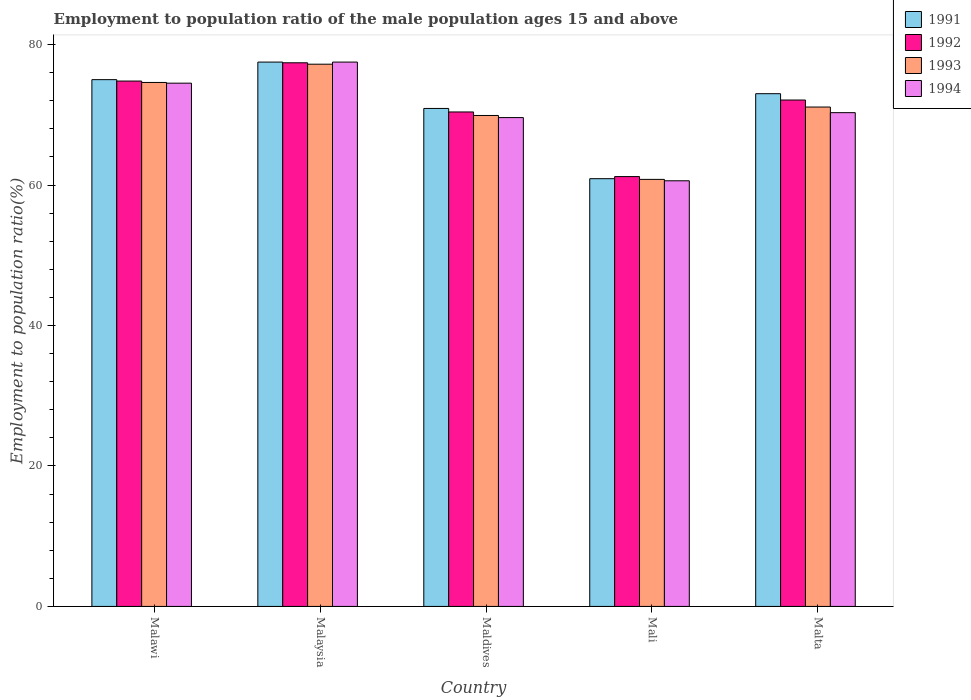How many different coloured bars are there?
Offer a terse response. 4. How many groups of bars are there?
Provide a succinct answer. 5. Are the number of bars per tick equal to the number of legend labels?
Provide a succinct answer. Yes. How many bars are there on the 5th tick from the right?
Provide a succinct answer. 4. What is the label of the 2nd group of bars from the left?
Make the answer very short. Malaysia. In how many cases, is the number of bars for a given country not equal to the number of legend labels?
Ensure brevity in your answer.  0. What is the employment to population ratio in 1993 in Malawi?
Your answer should be very brief. 74.6. Across all countries, what is the maximum employment to population ratio in 1994?
Provide a succinct answer. 77.5. Across all countries, what is the minimum employment to population ratio in 1991?
Your answer should be very brief. 60.9. In which country was the employment to population ratio in 1991 maximum?
Provide a short and direct response. Malaysia. In which country was the employment to population ratio in 1994 minimum?
Keep it short and to the point. Mali. What is the total employment to population ratio in 1993 in the graph?
Your answer should be compact. 353.6. What is the difference between the employment to population ratio in 1993 in Malaysia and that in Maldives?
Provide a succinct answer. 7.3. What is the difference between the employment to population ratio in 1993 in Mali and the employment to population ratio in 1992 in Malawi?
Ensure brevity in your answer.  -14. What is the average employment to population ratio in 1992 per country?
Your answer should be compact. 71.18. What is the difference between the employment to population ratio of/in 1992 and employment to population ratio of/in 1993 in Malaysia?
Your response must be concise. 0.2. What is the ratio of the employment to population ratio in 1993 in Malawi to that in Maldives?
Give a very brief answer. 1.07. Is the employment to population ratio in 1993 in Maldives less than that in Malta?
Your answer should be compact. Yes. What is the difference between the highest and the lowest employment to population ratio in 1991?
Your response must be concise. 16.6. Is it the case that in every country, the sum of the employment to population ratio in 1992 and employment to population ratio in 1993 is greater than the sum of employment to population ratio in 1991 and employment to population ratio in 1994?
Provide a succinct answer. No. What does the 3rd bar from the right in Malta represents?
Keep it short and to the point. 1992. How many bars are there?
Make the answer very short. 20. Are all the bars in the graph horizontal?
Your answer should be very brief. No. What is the difference between two consecutive major ticks on the Y-axis?
Provide a short and direct response. 20. Are the values on the major ticks of Y-axis written in scientific E-notation?
Offer a terse response. No. Does the graph contain any zero values?
Your response must be concise. No. Does the graph contain grids?
Provide a succinct answer. No. Where does the legend appear in the graph?
Your answer should be very brief. Top right. What is the title of the graph?
Your answer should be very brief. Employment to population ratio of the male population ages 15 and above. Does "1964" appear as one of the legend labels in the graph?
Your answer should be very brief. No. What is the Employment to population ratio(%) of 1991 in Malawi?
Provide a succinct answer. 75. What is the Employment to population ratio(%) of 1992 in Malawi?
Provide a short and direct response. 74.8. What is the Employment to population ratio(%) in 1993 in Malawi?
Your response must be concise. 74.6. What is the Employment to population ratio(%) in 1994 in Malawi?
Provide a succinct answer. 74.5. What is the Employment to population ratio(%) of 1991 in Malaysia?
Provide a short and direct response. 77.5. What is the Employment to population ratio(%) of 1992 in Malaysia?
Your response must be concise. 77.4. What is the Employment to population ratio(%) in 1993 in Malaysia?
Ensure brevity in your answer.  77.2. What is the Employment to population ratio(%) in 1994 in Malaysia?
Give a very brief answer. 77.5. What is the Employment to population ratio(%) of 1991 in Maldives?
Your answer should be very brief. 70.9. What is the Employment to population ratio(%) in 1992 in Maldives?
Your answer should be very brief. 70.4. What is the Employment to population ratio(%) of 1993 in Maldives?
Make the answer very short. 69.9. What is the Employment to population ratio(%) in 1994 in Maldives?
Keep it short and to the point. 69.6. What is the Employment to population ratio(%) of 1991 in Mali?
Offer a terse response. 60.9. What is the Employment to population ratio(%) of 1992 in Mali?
Your answer should be compact. 61.2. What is the Employment to population ratio(%) of 1993 in Mali?
Make the answer very short. 60.8. What is the Employment to population ratio(%) of 1994 in Mali?
Your answer should be compact. 60.6. What is the Employment to population ratio(%) in 1991 in Malta?
Keep it short and to the point. 73. What is the Employment to population ratio(%) in 1992 in Malta?
Make the answer very short. 72.1. What is the Employment to population ratio(%) of 1993 in Malta?
Keep it short and to the point. 71.1. What is the Employment to population ratio(%) in 1994 in Malta?
Offer a terse response. 70.3. Across all countries, what is the maximum Employment to population ratio(%) of 1991?
Provide a short and direct response. 77.5. Across all countries, what is the maximum Employment to population ratio(%) of 1992?
Give a very brief answer. 77.4. Across all countries, what is the maximum Employment to population ratio(%) of 1993?
Offer a terse response. 77.2. Across all countries, what is the maximum Employment to population ratio(%) of 1994?
Offer a very short reply. 77.5. Across all countries, what is the minimum Employment to population ratio(%) in 1991?
Offer a terse response. 60.9. Across all countries, what is the minimum Employment to population ratio(%) in 1992?
Give a very brief answer. 61.2. Across all countries, what is the minimum Employment to population ratio(%) of 1993?
Ensure brevity in your answer.  60.8. Across all countries, what is the minimum Employment to population ratio(%) in 1994?
Offer a very short reply. 60.6. What is the total Employment to population ratio(%) of 1991 in the graph?
Provide a succinct answer. 357.3. What is the total Employment to population ratio(%) of 1992 in the graph?
Provide a succinct answer. 355.9. What is the total Employment to population ratio(%) of 1993 in the graph?
Your answer should be very brief. 353.6. What is the total Employment to population ratio(%) of 1994 in the graph?
Provide a succinct answer. 352.5. What is the difference between the Employment to population ratio(%) in 1992 in Malawi and that in Malaysia?
Ensure brevity in your answer.  -2.6. What is the difference between the Employment to population ratio(%) in 1991 in Malawi and that in Maldives?
Provide a short and direct response. 4.1. What is the difference between the Employment to population ratio(%) of 1992 in Malawi and that in Maldives?
Keep it short and to the point. 4.4. What is the difference between the Employment to population ratio(%) of 1992 in Malawi and that in Mali?
Offer a terse response. 13.6. What is the difference between the Employment to population ratio(%) of 1992 in Malawi and that in Malta?
Provide a short and direct response. 2.7. What is the difference between the Employment to population ratio(%) of 1994 in Malawi and that in Malta?
Offer a terse response. 4.2. What is the difference between the Employment to population ratio(%) in 1991 in Malaysia and that in Maldives?
Give a very brief answer. 6.6. What is the difference between the Employment to population ratio(%) of 1992 in Malaysia and that in Maldives?
Your answer should be compact. 7. What is the difference between the Employment to population ratio(%) in 1994 in Malaysia and that in Maldives?
Your answer should be compact. 7.9. What is the difference between the Employment to population ratio(%) of 1992 in Malaysia and that in Mali?
Offer a terse response. 16.2. What is the difference between the Employment to population ratio(%) in 1991 in Malaysia and that in Malta?
Offer a terse response. 4.5. What is the difference between the Employment to population ratio(%) of 1992 in Malaysia and that in Malta?
Your response must be concise. 5.3. What is the difference between the Employment to population ratio(%) in 1994 in Malaysia and that in Malta?
Provide a succinct answer. 7.2. What is the difference between the Employment to population ratio(%) of 1991 in Maldives and that in Mali?
Make the answer very short. 10. What is the difference between the Employment to population ratio(%) of 1993 in Maldives and that in Mali?
Offer a very short reply. 9.1. What is the difference between the Employment to population ratio(%) in 1991 in Maldives and that in Malta?
Provide a succinct answer. -2.1. What is the difference between the Employment to population ratio(%) in 1991 in Mali and that in Malta?
Make the answer very short. -12.1. What is the difference between the Employment to population ratio(%) of 1993 in Mali and that in Malta?
Give a very brief answer. -10.3. What is the difference between the Employment to population ratio(%) in 1994 in Mali and that in Malta?
Your answer should be compact. -9.7. What is the difference between the Employment to population ratio(%) of 1991 in Malawi and the Employment to population ratio(%) of 1992 in Malaysia?
Offer a terse response. -2.4. What is the difference between the Employment to population ratio(%) in 1991 in Malawi and the Employment to population ratio(%) in 1994 in Malaysia?
Your response must be concise. -2.5. What is the difference between the Employment to population ratio(%) of 1993 in Malawi and the Employment to population ratio(%) of 1994 in Malaysia?
Offer a terse response. -2.9. What is the difference between the Employment to population ratio(%) of 1991 in Malawi and the Employment to population ratio(%) of 1992 in Maldives?
Provide a succinct answer. 4.6. What is the difference between the Employment to population ratio(%) in 1991 in Malawi and the Employment to population ratio(%) in 1993 in Maldives?
Make the answer very short. 5.1. What is the difference between the Employment to population ratio(%) in 1991 in Malawi and the Employment to population ratio(%) in 1994 in Maldives?
Make the answer very short. 5.4. What is the difference between the Employment to population ratio(%) in 1992 in Malawi and the Employment to population ratio(%) in 1993 in Maldives?
Your answer should be compact. 4.9. What is the difference between the Employment to population ratio(%) of 1992 in Malawi and the Employment to population ratio(%) of 1994 in Maldives?
Ensure brevity in your answer.  5.2. What is the difference between the Employment to population ratio(%) in 1993 in Malawi and the Employment to population ratio(%) in 1994 in Maldives?
Ensure brevity in your answer.  5. What is the difference between the Employment to population ratio(%) in 1991 in Malawi and the Employment to population ratio(%) in 1992 in Mali?
Your response must be concise. 13.8. What is the difference between the Employment to population ratio(%) in 1991 in Malawi and the Employment to population ratio(%) in 1993 in Mali?
Keep it short and to the point. 14.2. What is the difference between the Employment to population ratio(%) of 1991 in Malawi and the Employment to population ratio(%) of 1994 in Mali?
Your response must be concise. 14.4. What is the difference between the Employment to population ratio(%) in 1992 in Malawi and the Employment to population ratio(%) in 1993 in Mali?
Offer a very short reply. 14. What is the difference between the Employment to population ratio(%) in 1991 in Malawi and the Employment to population ratio(%) in 1992 in Malta?
Make the answer very short. 2.9. What is the difference between the Employment to population ratio(%) of 1991 in Malawi and the Employment to population ratio(%) of 1993 in Malta?
Provide a succinct answer. 3.9. What is the difference between the Employment to population ratio(%) in 1992 in Malawi and the Employment to population ratio(%) in 1994 in Malta?
Your answer should be very brief. 4.5. What is the difference between the Employment to population ratio(%) in 1992 in Malaysia and the Employment to population ratio(%) in 1993 in Maldives?
Keep it short and to the point. 7.5. What is the difference between the Employment to population ratio(%) in 1992 in Malaysia and the Employment to population ratio(%) in 1994 in Maldives?
Your answer should be very brief. 7.8. What is the difference between the Employment to population ratio(%) in 1993 in Malaysia and the Employment to population ratio(%) in 1994 in Maldives?
Give a very brief answer. 7.6. What is the difference between the Employment to population ratio(%) in 1991 in Malaysia and the Employment to population ratio(%) in 1993 in Mali?
Make the answer very short. 16.7. What is the difference between the Employment to population ratio(%) in 1991 in Malaysia and the Employment to population ratio(%) in 1994 in Mali?
Offer a terse response. 16.9. What is the difference between the Employment to population ratio(%) in 1992 in Malaysia and the Employment to population ratio(%) in 1994 in Mali?
Offer a very short reply. 16.8. What is the difference between the Employment to population ratio(%) in 1993 in Malaysia and the Employment to population ratio(%) in 1994 in Mali?
Ensure brevity in your answer.  16.6. What is the difference between the Employment to population ratio(%) in 1991 in Malaysia and the Employment to population ratio(%) in 1992 in Malta?
Your answer should be very brief. 5.4. What is the difference between the Employment to population ratio(%) of 1991 in Malaysia and the Employment to population ratio(%) of 1993 in Malta?
Make the answer very short. 6.4. What is the difference between the Employment to population ratio(%) in 1992 in Malaysia and the Employment to population ratio(%) in 1993 in Malta?
Your answer should be very brief. 6.3. What is the difference between the Employment to population ratio(%) of 1991 in Maldives and the Employment to population ratio(%) of 1994 in Mali?
Your answer should be very brief. 10.3. What is the difference between the Employment to population ratio(%) of 1992 in Maldives and the Employment to population ratio(%) of 1994 in Mali?
Offer a terse response. 9.8. What is the difference between the Employment to population ratio(%) in 1993 in Maldives and the Employment to population ratio(%) in 1994 in Mali?
Provide a short and direct response. 9.3. What is the difference between the Employment to population ratio(%) in 1992 in Maldives and the Employment to population ratio(%) in 1993 in Malta?
Your answer should be compact. -0.7. What is the difference between the Employment to population ratio(%) of 1992 in Maldives and the Employment to population ratio(%) of 1994 in Malta?
Offer a very short reply. 0.1. What is the difference between the Employment to population ratio(%) of 1993 in Maldives and the Employment to population ratio(%) of 1994 in Malta?
Make the answer very short. -0.4. What is the difference between the Employment to population ratio(%) of 1991 in Mali and the Employment to population ratio(%) of 1992 in Malta?
Your answer should be very brief. -11.2. What is the difference between the Employment to population ratio(%) of 1991 in Mali and the Employment to population ratio(%) of 1993 in Malta?
Keep it short and to the point. -10.2. What is the difference between the Employment to population ratio(%) in 1991 in Mali and the Employment to population ratio(%) in 1994 in Malta?
Offer a terse response. -9.4. What is the difference between the Employment to population ratio(%) in 1992 in Mali and the Employment to population ratio(%) in 1994 in Malta?
Offer a terse response. -9.1. What is the average Employment to population ratio(%) of 1991 per country?
Keep it short and to the point. 71.46. What is the average Employment to population ratio(%) in 1992 per country?
Make the answer very short. 71.18. What is the average Employment to population ratio(%) of 1993 per country?
Your answer should be compact. 70.72. What is the average Employment to population ratio(%) in 1994 per country?
Give a very brief answer. 70.5. What is the difference between the Employment to population ratio(%) in 1991 and Employment to population ratio(%) in 1993 in Malawi?
Make the answer very short. 0.4. What is the difference between the Employment to population ratio(%) of 1993 and Employment to population ratio(%) of 1994 in Malawi?
Ensure brevity in your answer.  0.1. What is the difference between the Employment to population ratio(%) in 1991 and Employment to population ratio(%) in 1993 in Malaysia?
Provide a short and direct response. 0.3. What is the difference between the Employment to population ratio(%) of 1991 and Employment to population ratio(%) of 1994 in Malaysia?
Ensure brevity in your answer.  0. What is the difference between the Employment to population ratio(%) of 1991 and Employment to population ratio(%) of 1992 in Maldives?
Provide a short and direct response. 0.5. What is the difference between the Employment to population ratio(%) in 1991 and Employment to population ratio(%) in 1994 in Maldives?
Offer a terse response. 1.3. What is the difference between the Employment to population ratio(%) in 1992 and Employment to population ratio(%) in 1993 in Maldives?
Your response must be concise. 0.5. What is the difference between the Employment to population ratio(%) of 1993 and Employment to population ratio(%) of 1994 in Maldives?
Keep it short and to the point. 0.3. What is the difference between the Employment to population ratio(%) of 1991 and Employment to population ratio(%) of 1993 in Mali?
Your response must be concise. 0.1. What is the difference between the Employment to population ratio(%) in 1992 and Employment to population ratio(%) in 1993 in Mali?
Give a very brief answer. 0.4. What is the difference between the Employment to population ratio(%) of 1992 and Employment to population ratio(%) of 1994 in Mali?
Your response must be concise. 0.6. What is the difference between the Employment to population ratio(%) in 1993 and Employment to population ratio(%) in 1994 in Mali?
Keep it short and to the point. 0.2. What is the difference between the Employment to population ratio(%) in 1991 and Employment to population ratio(%) in 1992 in Malta?
Offer a terse response. 0.9. What is the difference between the Employment to population ratio(%) of 1991 and Employment to population ratio(%) of 1994 in Malta?
Provide a short and direct response. 2.7. What is the difference between the Employment to population ratio(%) in 1992 and Employment to population ratio(%) in 1993 in Malta?
Provide a short and direct response. 1. What is the difference between the Employment to population ratio(%) of 1992 and Employment to population ratio(%) of 1994 in Malta?
Make the answer very short. 1.8. What is the ratio of the Employment to population ratio(%) in 1991 in Malawi to that in Malaysia?
Make the answer very short. 0.97. What is the ratio of the Employment to population ratio(%) in 1992 in Malawi to that in Malaysia?
Provide a succinct answer. 0.97. What is the ratio of the Employment to population ratio(%) in 1993 in Malawi to that in Malaysia?
Provide a succinct answer. 0.97. What is the ratio of the Employment to population ratio(%) in 1994 in Malawi to that in Malaysia?
Offer a very short reply. 0.96. What is the ratio of the Employment to population ratio(%) in 1991 in Malawi to that in Maldives?
Your answer should be compact. 1.06. What is the ratio of the Employment to population ratio(%) of 1993 in Malawi to that in Maldives?
Provide a short and direct response. 1.07. What is the ratio of the Employment to population ratio(%) in 1994 in Malawi to that in Maldives?
Offer a very short reply. 1.07. What is the ratio of the Employment to population ratio(%) in 1991 in Malawi to that in Mali?
Provide a succinct answer. 1.23. What is the ratio of the Employment to population ratio(%) of 1992 in Malawi to that in Mali?
Provide a short and direct response. 1.22. What is the ratio of the Employment to population ratio(%) of 1993 in Malawi to that in Mali?
Offer a terse response. 1.23. What is the ratio of the Employment to population ratio(%) of 1994 in Malawi to that in Mali?
Your answer should be compact. 1.23. What is the ratio of the Employment to population ratio(%) in 1991 in Malawi to that in Malta?
Your answer should be very brief. 1.03. What is the ratio of the Employment to population ratio(%) of 1992 in Malawi to that in Malta?
Your answer should be very brief. 1.04. What is the ratio of the Employment to population ratio(%) in 1993 in Malawi to that in Malta?
Give a very brief answer. 1.05. What is the ratio of the Employment to population ratio(%) in 1994 in Malawi to that in Malta?
Offer a very short reply. 1.06. What is the ratio of the Employment to population ratio(%) in 1991 in Malaysia to that in Maldives?
Your answer should be compact. 1.09. What is the ratio of the Employment to population ratio(%) of 1992 in Malaysia to that in Maldives?
Give a very brief answer. 1.1. What is the ratio of the Employment to population ratio(%) in 1993 in Malaysia to that in Maldives?
Your response must be concise. 1.1. What is the ratio of the Employment to population ratio(%) in 1994 in Malaysia to that in Maldives?
Your answer should be very brief. 1.11. What is the ratio of the Employment to population ratio(%) in 1991 in Malaysia to that in Mali?
Offer a terse response. 1.27. What is the ratio of the Employment to population ratio(%) in 1992 in Malaysia to that in Mali?
Your response must be concise. 1.26. What is the ratio of the Employment to population ratio(%) in 1993 in Malaysia to that in Mali?
Your answer should be very brief. 1.27. What is the ratio of the Employment to population ratio(%) of 1994 in Malaysia to that in Mali?
Make the answer very short. 1.28. What is the ratio of the Employment to population ratio(%) in 1991 in Malaysia to that in Malta?
Your response must be concise. 1.06. What is the ratio of the Employment to population ratio(%) in 1992 in Malaysia to that in Malta?
Your answer should be compact. 1.07. What is the ratio of the Employment to population ratio(%) of 1993 in Malaysia to that in Malta?
Give a very brief answer. 1.09. What is the ratio of the Employment to population ratio(%) of 1994 in Malaysia to that in Malta?
Your answer should be very brief. 1.1. What is the ratio of the Employment to population ratio(%) in 1991 in Maldives to that in Mali?
Give a very brief answer. 1.16. What is the ratio of the Employment to population ratio(%) of 1992 in Maldives to that in Mali?
Your answer should be very brief. 1.15. What is the ratio of the Employment to population ratio(%) in 1993 in Maldives to that in Mali?
Offer a very short reply. 1.15. What is the ratio of the Employment to population ratio(%) of 1994 in Maldives to that in Mali?
Provide a succinct answer. 1.15. What is the ratio of the Employment to population ratio(%) in 1991 in Maldives to that in Malta?
Ensure brevity in your answer.  0.97. What is the ratio of the Employment to population ratio(%) in 1992 in Maldives to that in Malta?
Offer a terse response. 0.98. What is the ratio of the Employment to population ratio(%) of 1993 in Maldives to that in Malta?
Offer a very short reply. 0.98. What is the ratio of the Employment to population ratio(%) of 1991 in Mali to that in Malta?
Make the answer very short. 0.83. What is the ratio of the Employment to population ratio(%) in 1992 in Mali to that in Malta?
Your response must be concise. 0.85. What is the ratio of the Employment to population ratio(%) of 1993 in Mali to that in Malta?
Give a very brief answer. 0.86. What is the ratio of the Employment to population ratio(%) of 1994 in Mali to that in Malta?
Offer a very short reply. 0.86. What is the difference between the highest and the second highest Employment to population ratio(%) in 1991?
Give a very brief answer. 2.5. What is the difference between the highest and the second highest Employment to population ratio(%) in 1992?
Your answer should be compact. 2.6. What is the difference between the highest and the lowest Employment to population ratio(%) in 1992?
Keep it short and to the point. 16.2. What is the difference between the highest and the lowest Employment to population ratio(%) of 1994?
Make the answer very short. 16.9. 